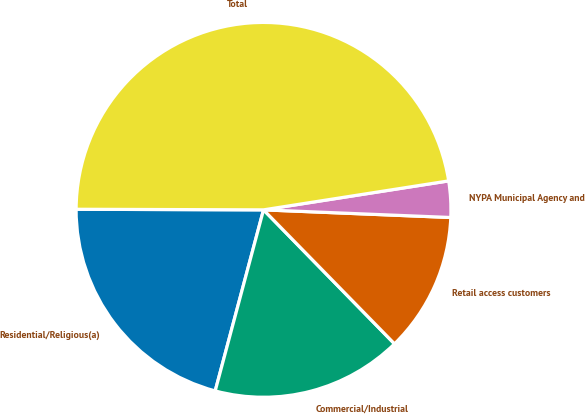Convert chart to OTSL. <chart><loc_0><loc_0><loc_500><loc_500><pie_chart><fcel>Residential/Religious(a)<fcel>Commercial/Industrial<fcel>Retail access customers<fcel>NYPA Municipal Agency and<fcel>Total<nl><fcel>20.9%<fcel>16.47%<fcel>12.03%<fcel>3.12%<fcel>47.48%<nl></chart> 